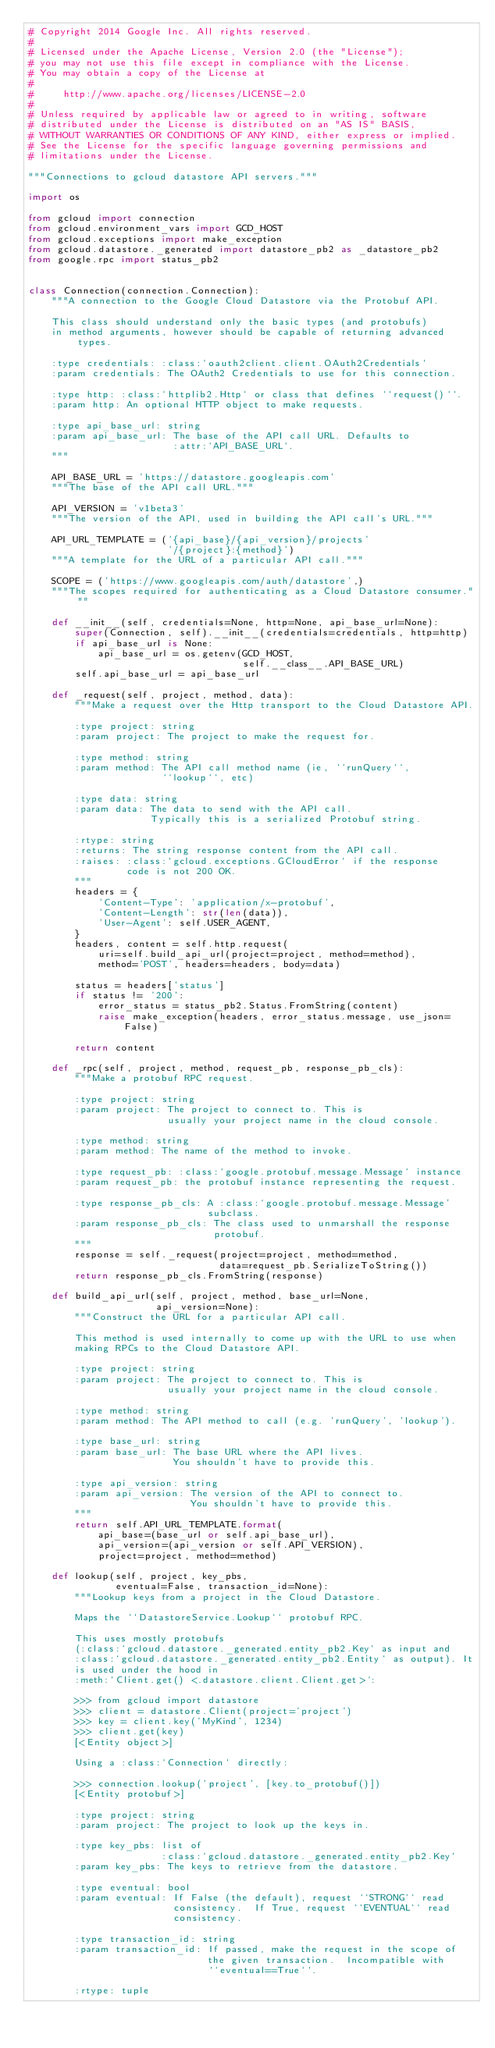Convert code to text. <code><loc_0><loc_0><loc_500><loc_500><_Python_># Copyright 2014 Google Inc. All rights reserved.
#
# Licensed under the Apache License, Version 2.0 (the "License");
# you may not use this file except in compliance with the License.
# You may obtain a copy of the License at
#
#     http://www.apache.org/licenses/LICENSE-2.0
#
# Unless required by applicable law or agreed to in writing, software
# distributed under the License is distributed on an "AS IS" BASIS,
# WITHOUT WARRANTIES OR CONDITIONS OF ANY KIND, either express or implied.
# See the License for the specific language governing permissions and
# limitations under the License.

"""Connections to gcloud datastore API servers."""

import os

from gcloud import connection
from gcloud.environment_vars import GCD_HOST
from gcloud.exceptions import make_exception
from gcloud.datastore._generated import datastore_pb2 as _datastore_pb2
from google.rpc import status_pb2


class Connection(connection.Connection):
    """A connection to the Google Cloud Datastore via the Protobuf API.

    This class should understand only the basic types (and protobufs)
    in method arguments, however should be capable of returning advanced types.

    :type credentials: :class:`oauth2client.client.OAuth2Credentials`
    :param credentials: The OAuth2 Credentials to use for this connection.

    :type http: :class:`httplib2.Http` or class that defines ``request()``.
    :param http: An optional HTTP object to make requests.

    :type api_base_url: string
    :param api_base_url: The base of the API call URL. Defaults to
                         :attr:`API_BASE_URL`.
    """

    API_BASE_URL = 'https://datastore.googleapis.com'
    """The base of the API call URL."""

    API_VERSION = 'v1beta3'
    """The version of the API, used in building the API call's URL."""

    API_URL_TEMPLATE = ('{api_base}/{api_version}/projects'
                        '/{project}:{method}')
    """A template for the URL of a particular API call."""

    SCOPE = ('https://www.googleapis.com/auth/datastore',)
    """The scopes required for authenticating as a Cloud Datastore consumer."""

    def __init__(self, credentials=None, http=None, api_base_url=None):
        super(Connection, self).__init__(credentials=credentials, http=http)
        if api_base_url is None:
            api_base_url = os.getenv(GCD_HOST,
                                     self.__class__.API_BASE_URL)
        self.api_base_url = api_base_url

    def _request(self, project, method, data):
        """Make a request over the Http transport to the Cloud Datastore API.

        :type project: string
        :param project: The project to make the request for.

        :type method: string
        :param method: The API call method name (ie, ``runQuery``,
                       ``lookup``, etc)

        :type data: string
        :param data: The data to send with the API call.
                     Typically this is a serialized Protobuf string.

        :rtype: string
        :returns: The string response content from the API call.
        :raises: :class:`gcloud.exceptions.GCloudError` if the response
                 code is not 200 OK.
        """
        headers = {
            'Content-Type': 'application/x-protobuf',
            'Content-Length': str(len(data)),
            'User-Agent': self.USER_AGENT,
        }
        headers, content = self.http.request(
            uri=self.build_api_url(project=project, method=method),
            method='POST', headers=headers, body=data)

        status = headers['status']
        if status != '200':
            error_status = status_pb2.Status.FromString(content)
            raise make_exception(headers, error_status.message, use_json=False)

        return content

    def _rpc(self, project, method, request_pb, response_pb_cls):
        """Make a protobuf RPC request.

        :type project: string
        :param project: The project to connect to. This is
                        usually your project name in the cloud console.

        :type method: string
        :param method: The name of the method to invoke.

        :type request_pb: :class:`google.protobuf.message.Message` instance
        :param request_pb: the protobuf instance representing the request.

        :type response_pb_cls: A :class:`google.protobuf.message.Message'
                               subclass.
        :param response_pb_cls: The class used to unmarshall the response
                                protobuf.
        """
        response = self._request(project=project, method=method,
                                 data=request_pb.SerializeToString())
        return response_pb_cls.FromString(response)

    def build_api_url(self, project, method, base_url=None,
                      api_version=None):
        """Construct the URL for a particular API call.

        This method is used internally to come up with the URL to use when
        making RPCs to the Cloud Datastore API.

        :type project: string
        :param project: The project to connect to. This is
                        usually your project name in the cloud console.

        :type method: string
        :param method: The API method to call (e.g. 'runQuery', 'lookup').

        :type base_url: string
        :param base_url: The base URL where the API lives.
                         You shouldn't have to provide this.

        :type api_version: string
        :param api_version: The version of the API to connect to.
                            You shouldn't have to provide this.
        """
        return self.API_URL_TEMPLATE.format(
            api_base=(base_url or self.api_base_url),
            api_version=(api_version or self.API_VERSION),
            project=project, method=method)

    def lookup(self, project, key_pbs,
               eventual=False, transaction_id=None):
        """Lookup keys from a project in the Cloud Datastore.

        Maps the ``DatastoreService.Lookup`` protobuf RPC.

        This uses mostly protobufs
        (:class:`gcloud.datastore._generated.entity_pb2.Key` as input and
        :class:`gcloud.datastore._generated.entity_pb2.Entity` as output). It
        is used under the hood in
        :meth:`Client.get() <.datastore.client.Client.get>`:

        >>> from gcloud import datastore
        >>> client = datastore.Client(project='project')
        >>> key = client.key('MyKind', 1234)
        >>> client.get(key)
        [<Entity object>]

        Using a :class:`Connection` directly:

        >>> connection.lookup('project', [key.to_protobuf()])
        [<Entity protobuf>]

        :type project: string
        :param project: The project to look up the keys in.

        :type key_pbs: list of
                       :class:`gcloud.datastore._generated.entity_pb2.Key`
        :param key_pbs: The keys to retrieve from the datastore.

        :type eventual: bool
        :param eventual: If False (the default), request ``STRONG`` read
                         consistency.  If True, request ``EVENTUAL`` read
                         consistency.

        :type transaction_id: string
        :param transaction_id: If passed, make the request in the scope of
                               the given transaction.  Incompatible with
                               ``eventual==True``.

        :rtype: tuple</code> 